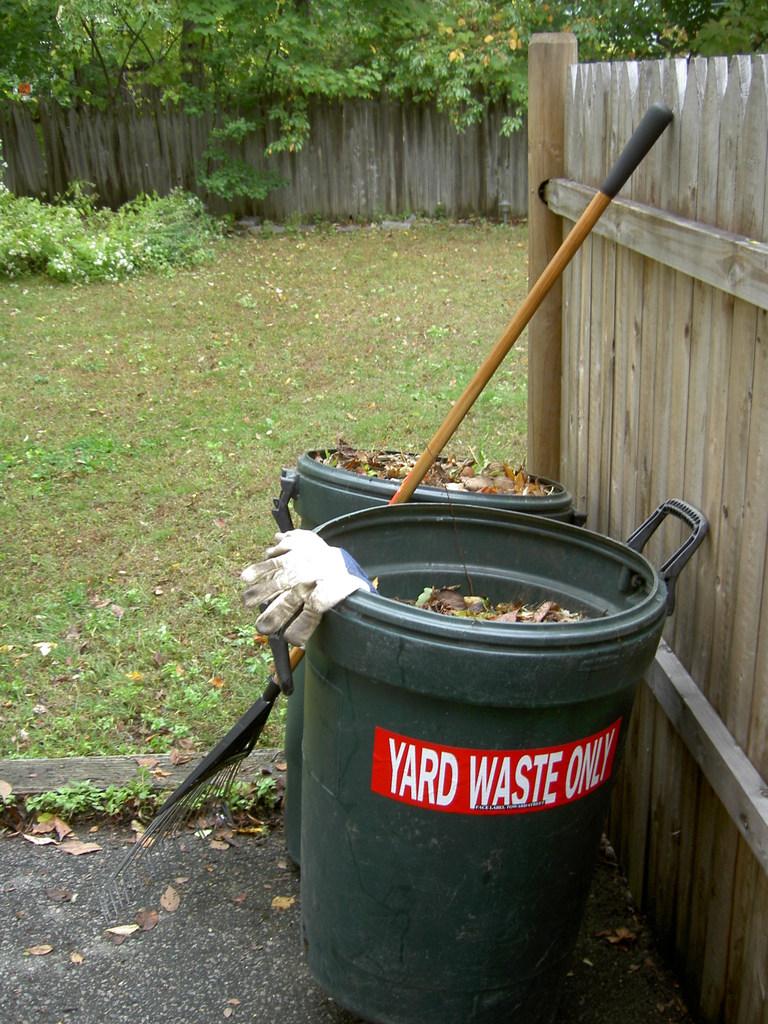What is this bin for?
Offer a very short reply. Yard waste. What kind of waste?
Give a very brief answer. Yard. 